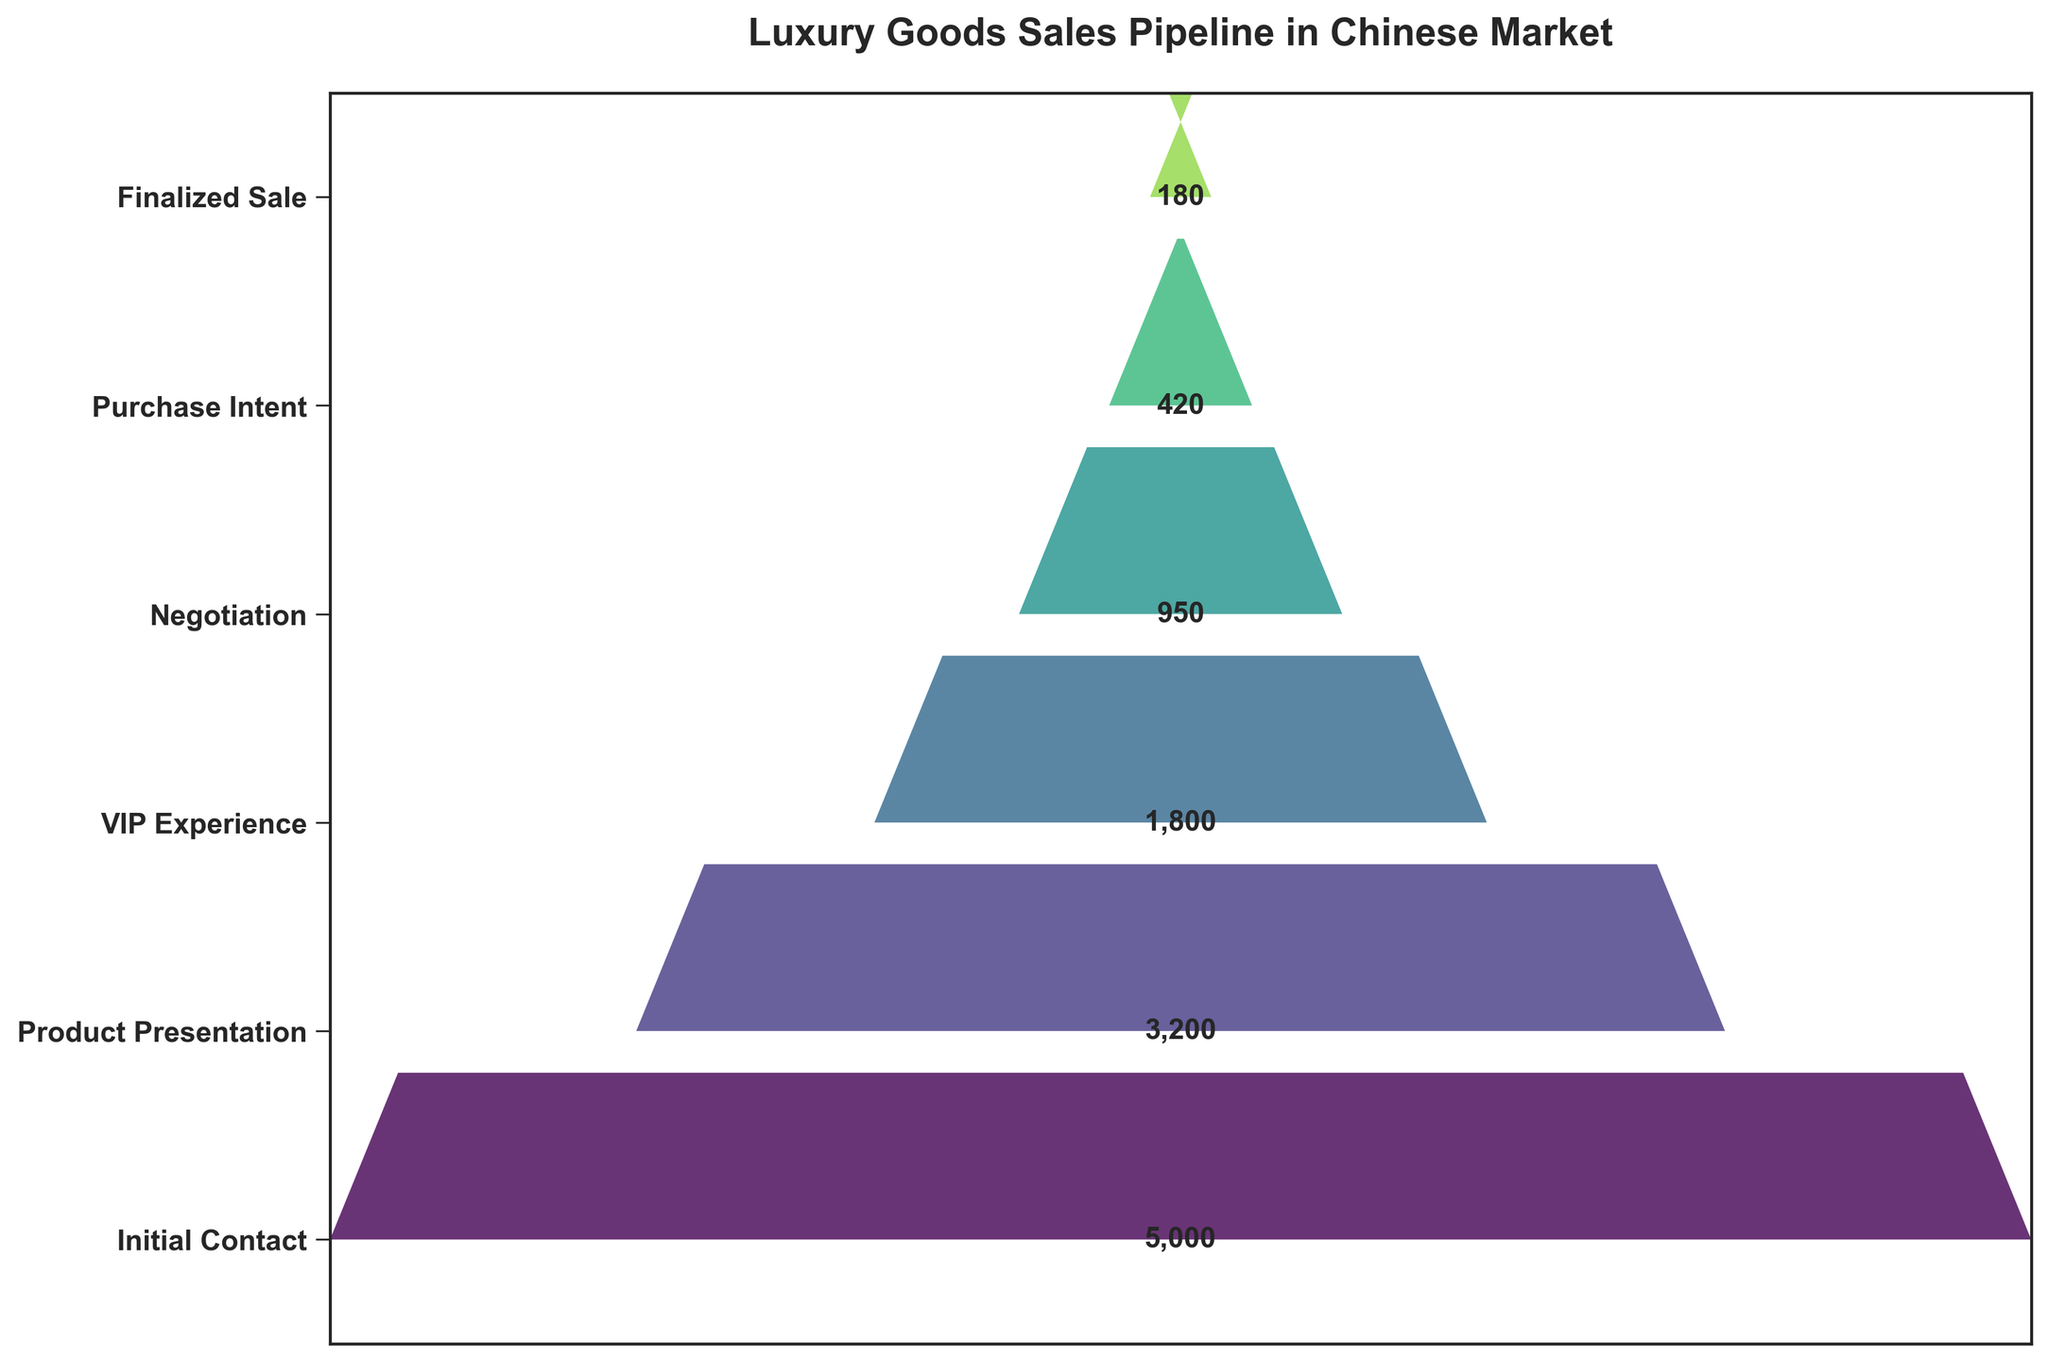what is the title of the figure? The text at the top of the figure in bold represents the title. The title is written as ‘Luxury Goods Sales Pipeline in Chinese Market.’
Answer: Luxury Goods Sales Pipeline in Chinese Market how many sales pipeline stages are shown in the funnel chart? Count the individual stages listed on the y-axis of the chart. Here, the stages are 'Initial Contact,' 'Product Presentation,' 'VIP Experience,' 'Negotiation,' 'Purchase Intent,' and 'Finalized Sale.’
Answer: 6 which sales pipeline stage has the highest number of leads? Observing the length of the bars from left to right, the stage with the widest bar represents the highest number of leads. In this case, it is the ‘Initial Contact’ stage.
Answer: Initial Contact by how much does the number of leads decrease from the 'VIP Experience' stage to the 'Negotiation' stage? 'VIP Experience' has 1,800 leads, and 'Negotiation' has 950 leads. Subtract the leads in 'Negotiation' from 'VIP Experience' (1800 - 950). The decrease is 850 leads.
Answer: 850 which stage represents a drop of more than 50% in the number of leads from the previous stage? Calculate the percentage drop between consecutive stages. One significant drop is from 'Product Presentation' (3,200 leads) to 'VIP Experience' (1,800 leads). The drop percentage is \(\frac{3200 - 1800}{3200} × 100 = 43.75%\). Another drop is from 'Negotiation' (950) to 'Purchase Intent' (420) giving us \(\frac{950 - 420}{950} × 100 = 55.79%\). The latter is greater than 50%.
Answer: Negotiation to Purchase Intent calculate the total number of leads at the 'Finalized Sale' stage as a percentage of those in the 'Initial Contact' stage Divide the number of leads in 'Finalized Sale' (180) by the number of leads in 'Initial Contact' (5000) and multiply by 100 to get the percentage \(\frac{180}{5000} × 100\)
Answer: 3.6% by how much do the leads reduce from 'Initial Contact' to the final stage of 'Finalized Sale'? Subtract the number of leads in 'Finalized Sale' from 'Initial Contact' (5000 - 180).
Answer: 4820 is the transition from 'Product Presentation' to 'VIP Experience' more significant than from 'VIP Experience' to 'Negotiation' stage in terms of the number of leads? Calculate the difference in leads between each transition. From 'Product Presentation' (3200) to 'VIP Experience' (1800), the reduction is 3200 - 1800 = 1400. From 'VIP Experience' (1800) to 'Negotiation' (950), the reduction is 1800 - 950 = 850. Since 1400 > 850, the first transition is more significant.
Answer: Yes what is the ratio of 'Purchase Intent' leads compared to 'Negotiation' leads? Divide the number of 'Purchase Intent' leads by 'Negotiation' leads (420 / 950) and simplify if possible.
Answer: 0.44 